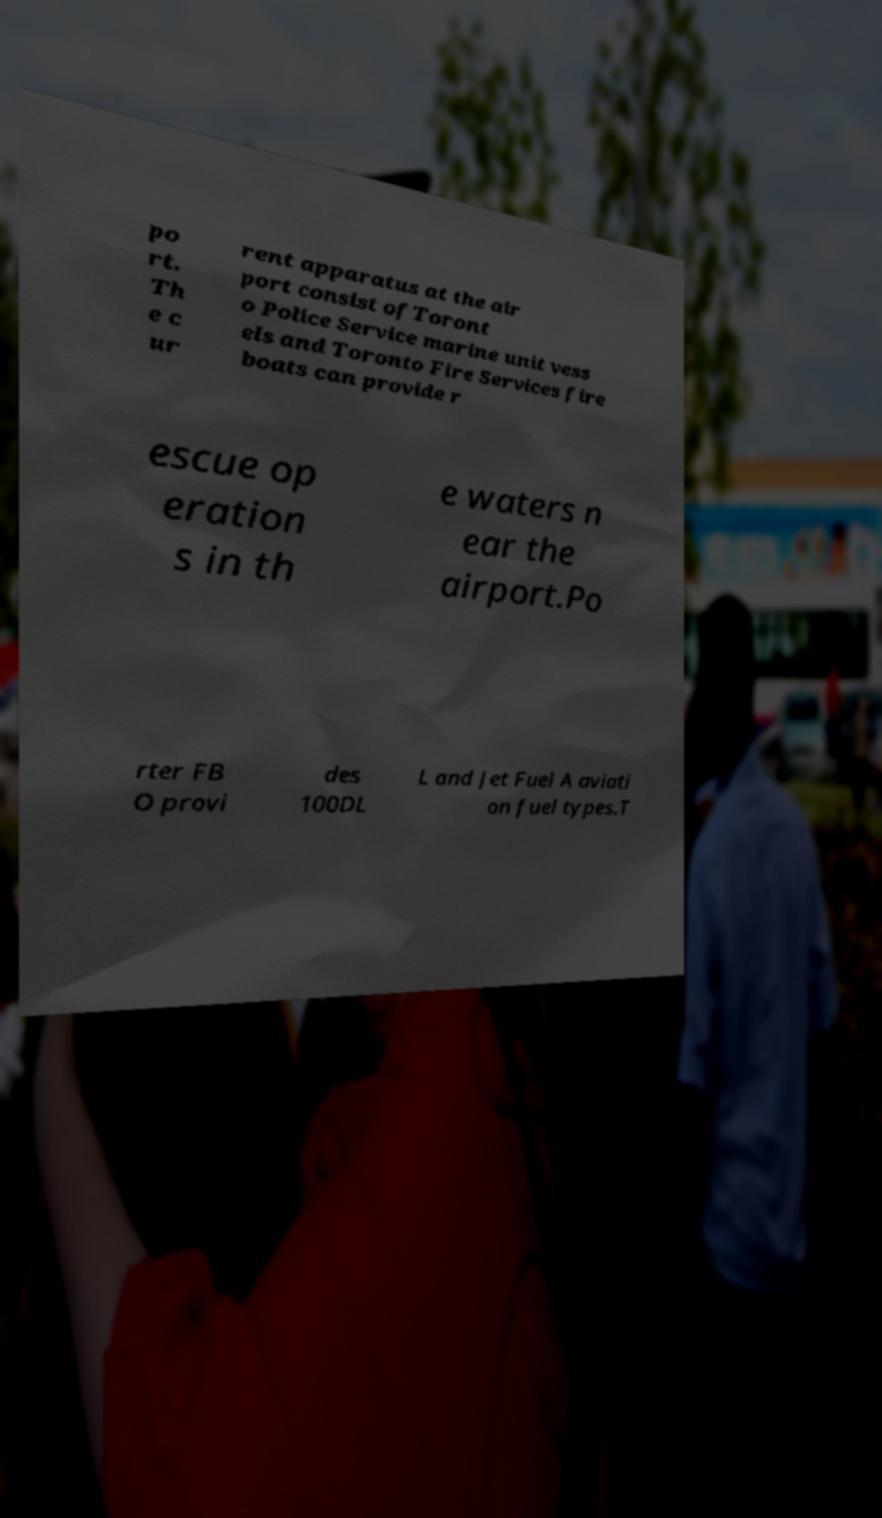I need the written content from this picture converted into text. Can you do that? po rt. Th e c ur rent apparatus at the air port consist ofToront o Police Service marine unit vess els and Toronto Fire Services fire boats can provide r escue op eration s in th e waters n ear the airport.Po rter FB O provi des 100DL L and Jet Fuel A aviati on fuel types.T 